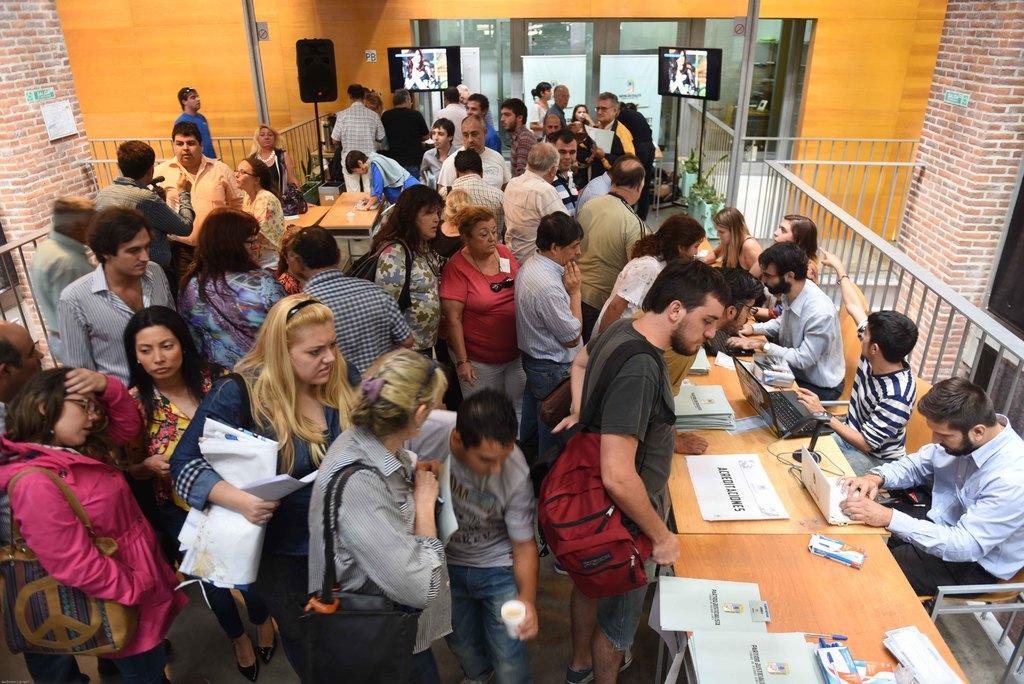How would you summarize this image in a sentence or two? In this picture I can see few people are sitting in the chairs and few people are standing and I can see papers, laptops on the tables and I can see couple of televisions and a speaker and I can see a man holding a cup in his hand and few of them wearing bags and it looks like a inner view of a building. 